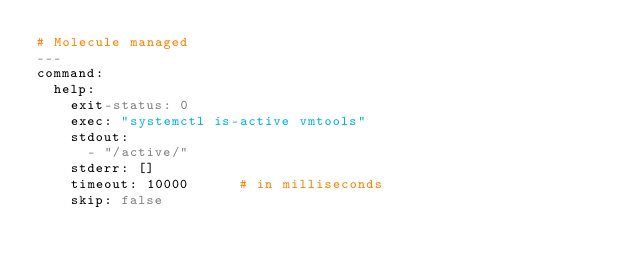Convert code to text. <code><loc_0><loc_0><loc_500><loc_500><_YAML_># Molecule managed
---
command:
  help:
    exit-status: 0
    exec: "systemctl is-active vmtools"
    stdout:
      - "/active/"
    stderr: []
    timeout: 10000      # in milliseconds
    skip: false
</code> 